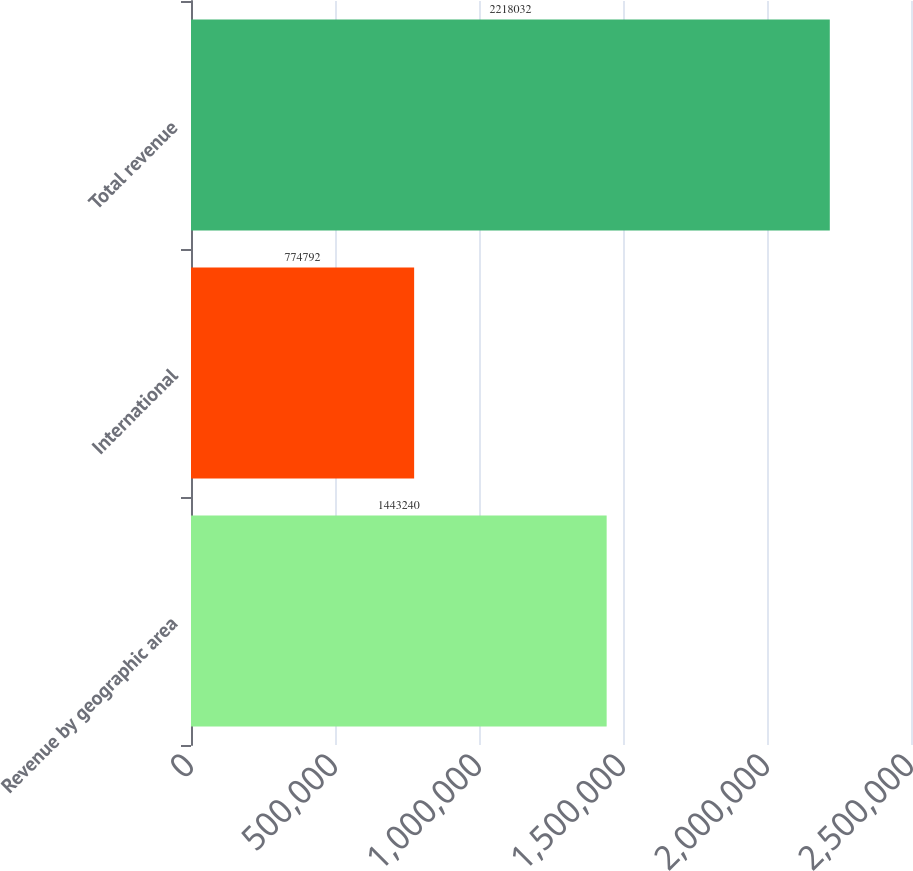Convert chart to OTSL. <chart><loc_0><loc_0><loc_500><loc_500><bar_chart><fcel>Revenue by geographic area<fcel>International<fcel>Total revenue<nl><fcel>1.44324e+06<fcel>774792<fcel>2.21803e+06<nl></chart> 